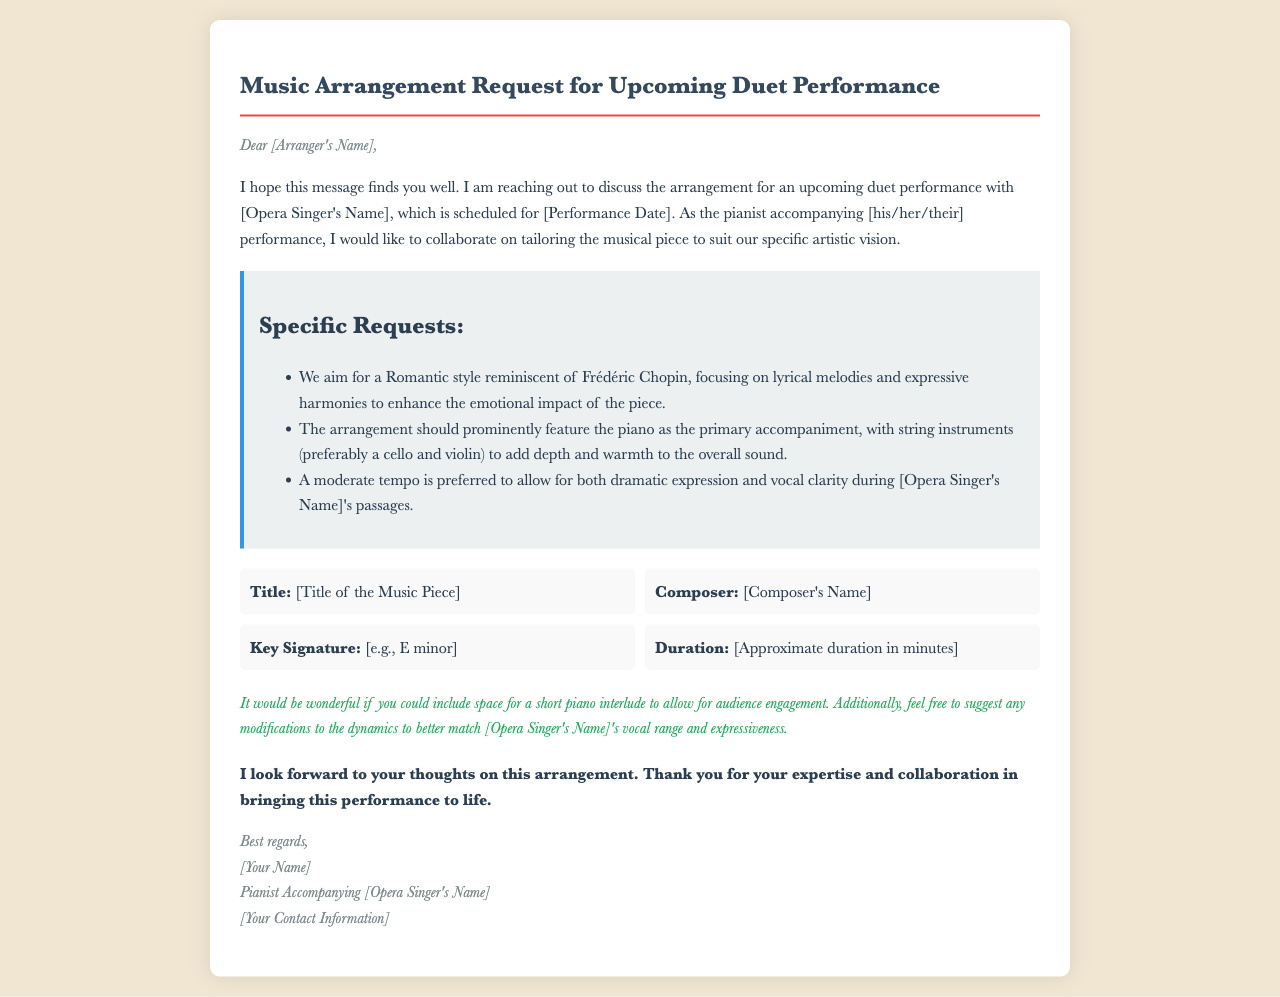What is the title of the music piece? The title of the music piece is specified in the document as [Title of the Music Piece].
Answer: [Title of the Music Piece] Who is the opera singer mentioned? The opera singer is referenced as [Opera Singer's Name] in the document.
Answer: [Opera Singer's Name] What is the preferred style for the arrangement? The document states that the preferred style is Romantic, reminiscent of Frédéric Chopin.
Answer: Romantic What instruments are requested for the arrangement? The request specifies that string instruments, preferably a cello and violin, should be included.
Answer: Cello and violin What is the preferred tempo for the arrangement? The document indicates a moderate tempo is preferred for the performance.
Answer: Moderate When is the duet performance scheduled? The specific date for the performance is mentioned as [Performance Date].
Answer: [Performance Date] What is the purpose of including a short piano interlude? The interlude is meant to allow for audience engagement during the performance.
Answer: Audience engagement What does the pianist hope to achieve with the arrangement? The pianist aims to enhance the emotional impact of the piece through a tailored arrangement.
Answer: Enhance emotional impact 